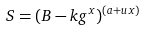Convert formula to latex. <formula><loc_0><loc_0><loc_500><loc_500>S = ( B - k g ^ { x } ) ^ { ( a + u x ) }</formula> 